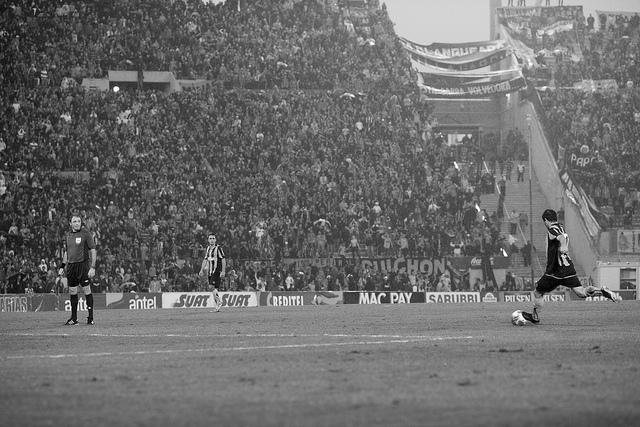Is this a professional game?
Be succinct. Yes. How many people are in the stadium?
Short answer required. Lot. Is this sport known to have cheerleaders?
Keep it brief. No. 